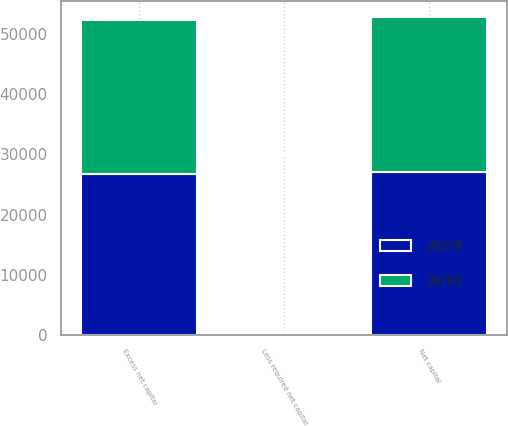Convert chart to OTSL. <chart><loc_0><loc_0><loc_500><loc_500><stacked_bar_chart><ecel><fcel>Net capital<fcel>Less required net capital<fcel>Excess net capital<nl><fcel>25578<fcel>27013<fcel>250<fcel>26763<nl><fcel>26763<fcel>25828<fcel>250<fcel>25578<nl></chart> 